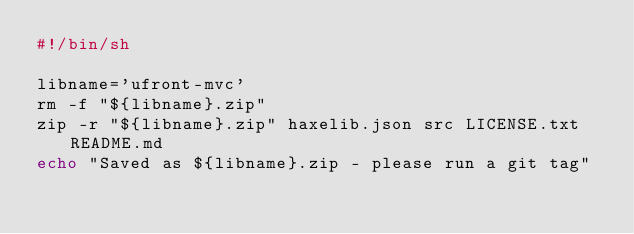Convert code to text. <code><loc_0><loc_0><loc_500><loc_500><_Bash_>#!/bin/sh

libname='ufront-mvc'
rm -f "${libname}.zip"
zip -r "${libname}.zip" haxelib.json src LICENSE.txt README.md
echo "Saved as ${libname}.zip - please run a git tag"
</code> 